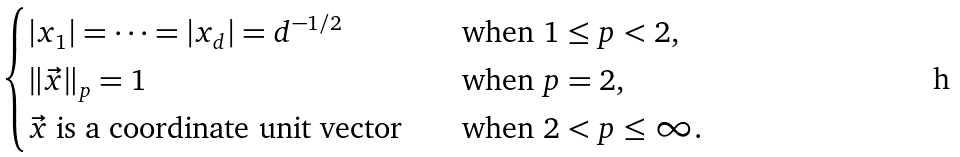<formula> <loc_0><loc_0><loc_500><loc_500>\begin{cases} | x _ { 1 } | = \cdots = | x _ { d } | = d ^ { - 1 / 2 } & \quad \text {when } 1 \leq p < 2 , \\ \| \vec { x } \| _ { p } = 1 & \quad \text {when } p = 2 , \\ \vec { x } \text { is a coordinate unit vector} & \quad \text {when } 2 < p \leq \infty . \end{cases}</formula> 